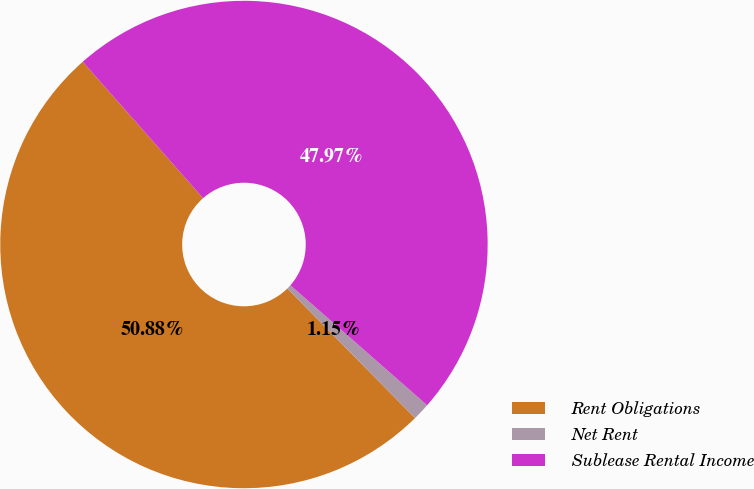Convert chart to OTSL. <chart><loc_0><loc_0><loc_500><loc_500><pie_chart><fcel>Rent Obligations<fcel>Net Rent<fcel>Sublease Rental Income<nl><fcel>50.88%<fcel>1.15%<fcel>47.97%<nl></chart> 